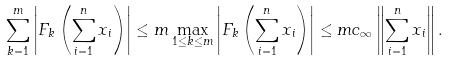<formula> <loc_0><loc_0><loc_500><loc_500>\sum _ { k = 1 } ^ { m } \left | F _ { k } \left ( \sum _ { i = 1 } ^ { n } x _ { i } \right ) \right | \leq m \max _ { 1 \leq k \leq m } \left | F _ { k } \left ( \sum _ { i = 1 } ^ { n } x _ { i } \right ) \right | \leq m c _ { \infty } \left \| \sum _ { i = 1 } ^ { n } x _ { i } \right \| .</formula> 